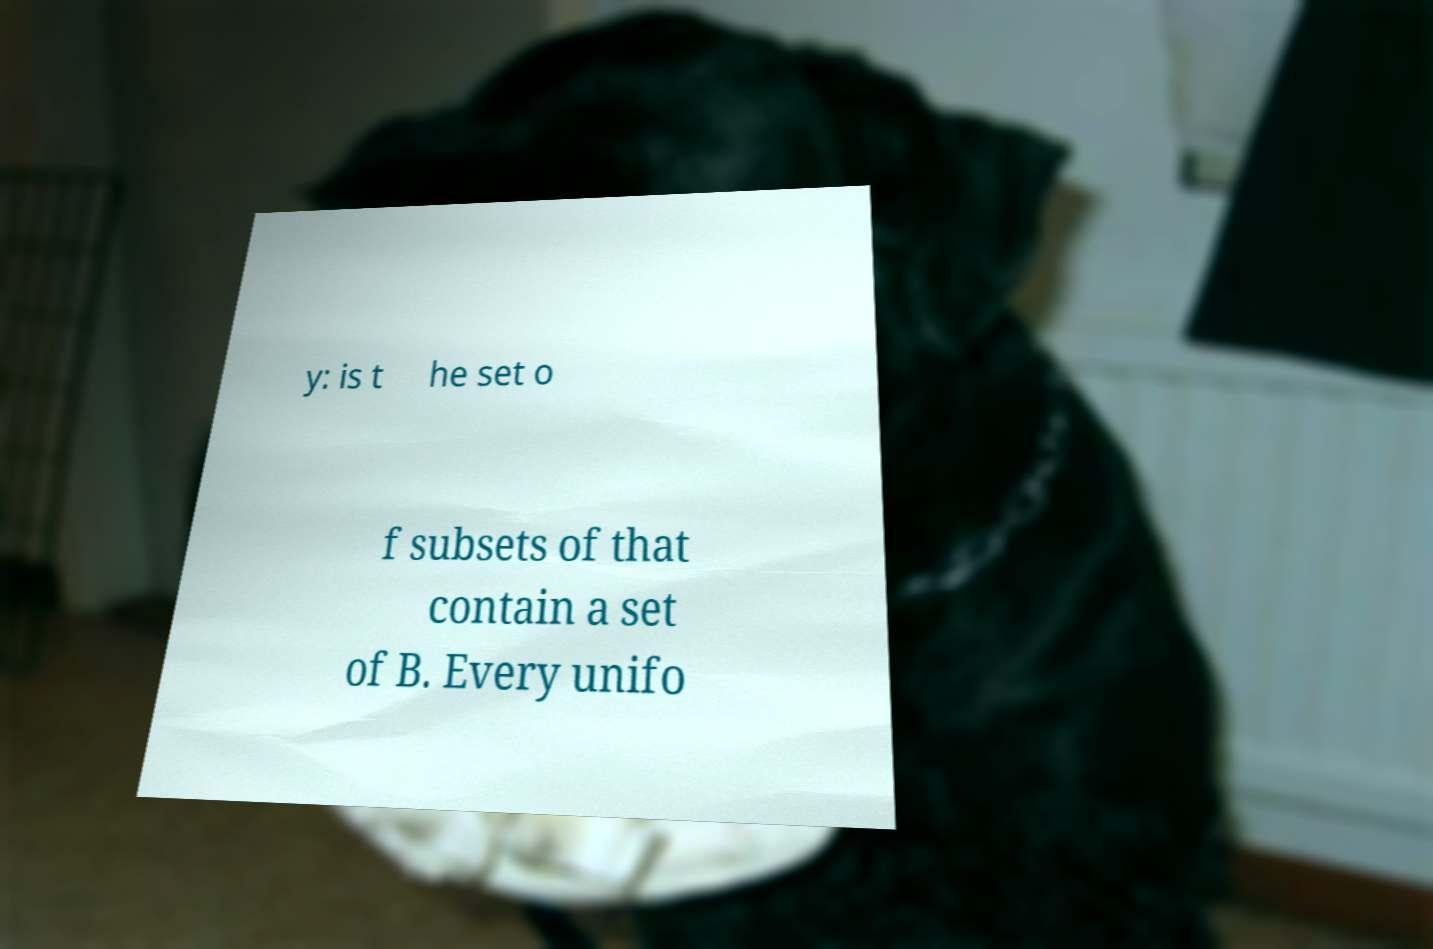For documentation purposes, I need the text within this image transcribed. Could you provide that? y: is t he set o f subsets of that contain a set of B. Every unifo 